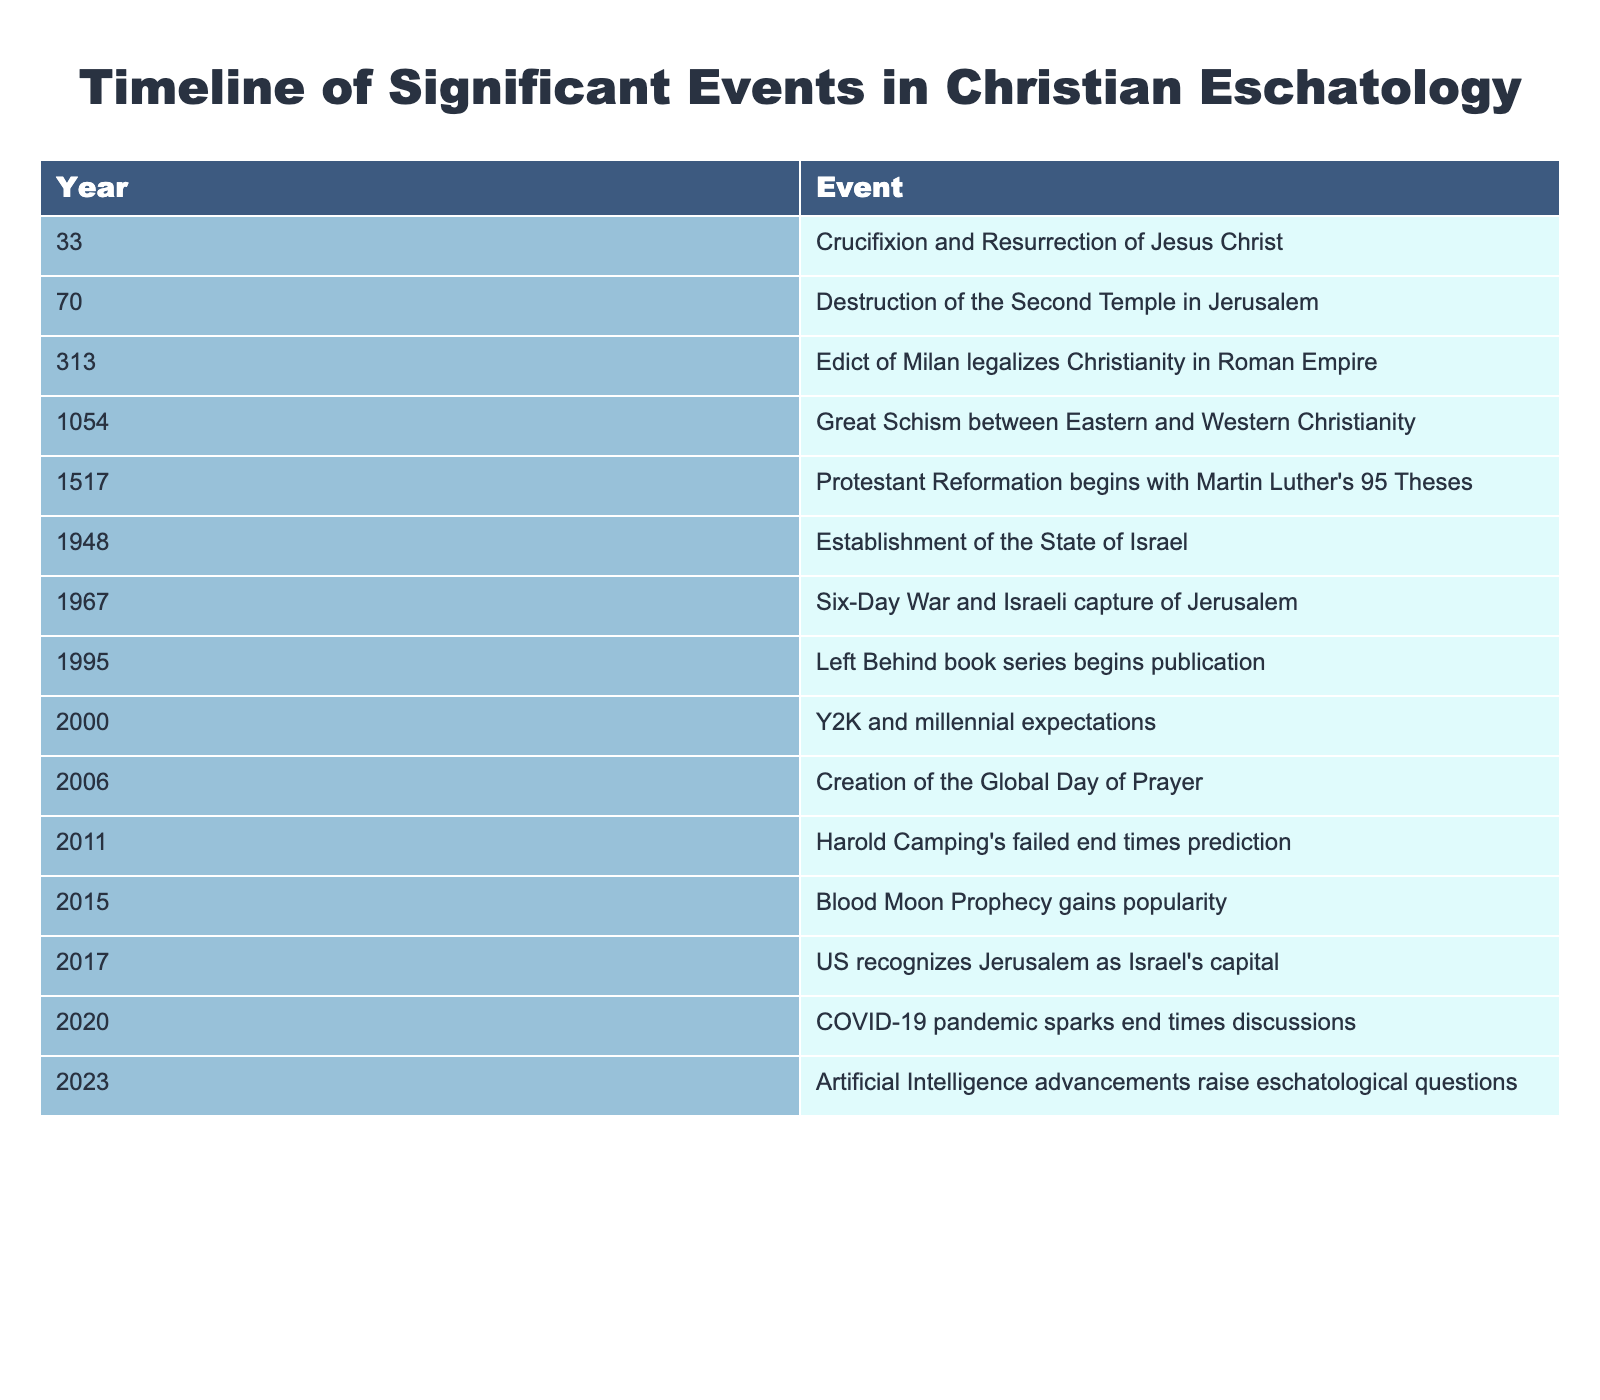What event occurred in the year 70? The table lists "Destruction of the Second Temple in Jerusalem" as the event for the year 70.
Answer: Destruction of the Second Temple in Jerusalem Which event is noted as happening in 1517? According to the table, the event that occurred in 1517 is the "Protestant Reformation begins with Martin Luther's 95 Theses."
Answer: Protestant Reformation begins How many events are listed between the years 1948 and 2017? The events listed in the specified range are: 1948 (Establishment of the State of Israel), 1967 (Six-Day War), and 2017 (US recognizes Jerusalem as Israel's capital), totaling 3 events.
Answer: 3 Was the establishment of the State of Israel in 1948 followed by an event related to Jerusalem? Yes, the event in 1967 (Six-Day War and Israeli capture of Jerusalem) occurred after the establishment of Israel in 1948, indicating a connection to Jerusalem.
Answer: Yes What is the difference in years between the Crucifixion of Jesus and the Protestant Reformation? The Crucifixion of Jesus occurred in 33, while the Protestant Reformation began in 1517, resulting in a difference of 1517 - 33 = 1484 years.
Answer: 1484 Which event is the most recent in this timeline? The most recent event according to the table is "Artificial Intelligence advancements raise eschatological questions" in the year 2023.
Answer: Artificial Intelligence advancements How many events from the timeline are connected to predictions about the end times? The table mentions three events related to end times predictions: 1995 (Left Behind book series begins), 2011 (Harold Camping's failed prediction), and 2015 (Blood Moon Prophecy gains popularity), totaling 3 events.
Answer: 3 In which decade did the Great Schism occur and what was its significance related to Christianity? The Great Schism occurred in the 11th century (1054), marking a significant divide between Eastern and Western Christianity.
Answer: 11th century, divide in Christianity What was the primary focus of events listed from 2000 to 2023? The events from 2000 to 2023 primarily focus on expectations and discussions surrounding end times and eschatology.
Answer: End times focus 